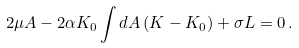Convert formula to latex. <formula><loc_0><loc_0><loc_500><loc_500>2 \mu A - 2 \alpha K _ { 0 } \int d A \, ( K - K _ { 0 } ) + \sigma L = 0 \, .</formula> 